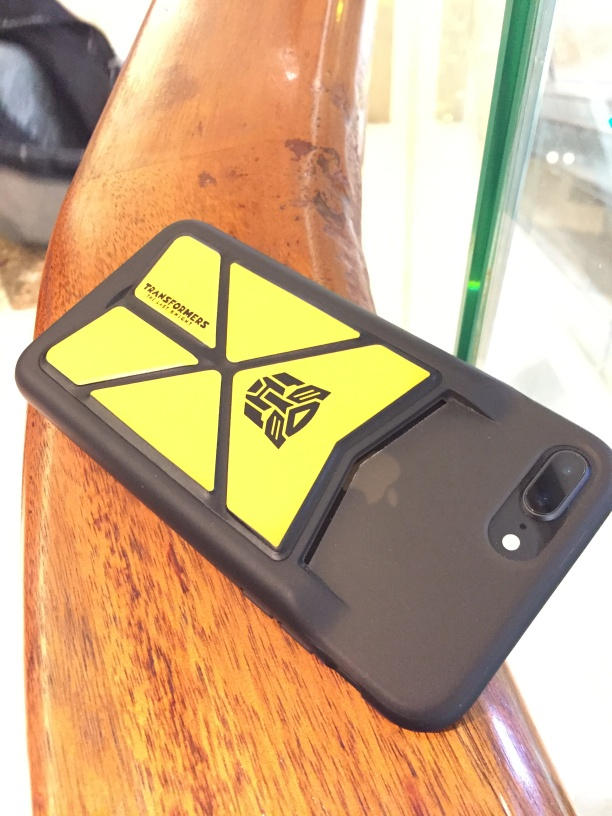Are there any quality issues with this image? Yes, there are noticeable quality issues with the image. There appears to be slight blurring, which affects the overall sharpness and could be due to motion or focus adjustment at the time the photo was taken. Additionally, there is some glare on the top edge that slightly obscures detail and the lighting seems uneven, impacting the visibility of the phone case details. 